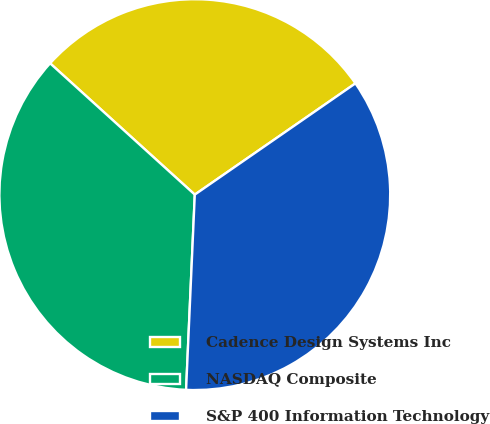Convert chart to OTSL. <chart><loc_0><loc_0><loc_500><loc_500><pie_chart><fcel>Cadence Design Systems Inc<fcel>NASDAQ Composite<fcel>S&P 400 Information Technology<nl><fcel>28.63%<fcel>36.02%<fcel>35.35%<nl></chart> 